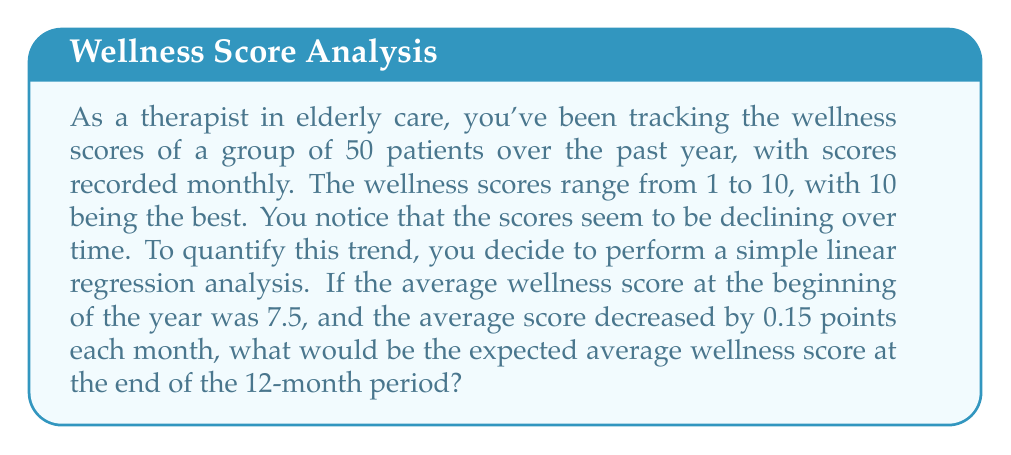Help me with this question. To solve this problem, we'll use the simple linear regression equation:

$$y = mx + b$$

Where:
$y$ = wellness score
$m$ = slope (rate of change per month)
$x$ = number of months
$b$ = y-intercept (initial wellness score)

Given:
- Initial average wellness score (b) = 7.5
- Rate of decrease per month (m) = -0.15
- Time period = 12 months

We want to find the wellness score (y) after 12 months (x = 12).

Step 1: Substitute the known values into the equation:
$$y = -0.15x + 7.5$$

Step 2: Calculate y when x = 12:
$$y = -0.15(12) + 7.5$$
$$y = -1.8 + 7.5$$
$$y = 5.7$$

Therefore, the expected average wellness score at the end of the 12-month period would be 5.7.
Answer: 5.7 